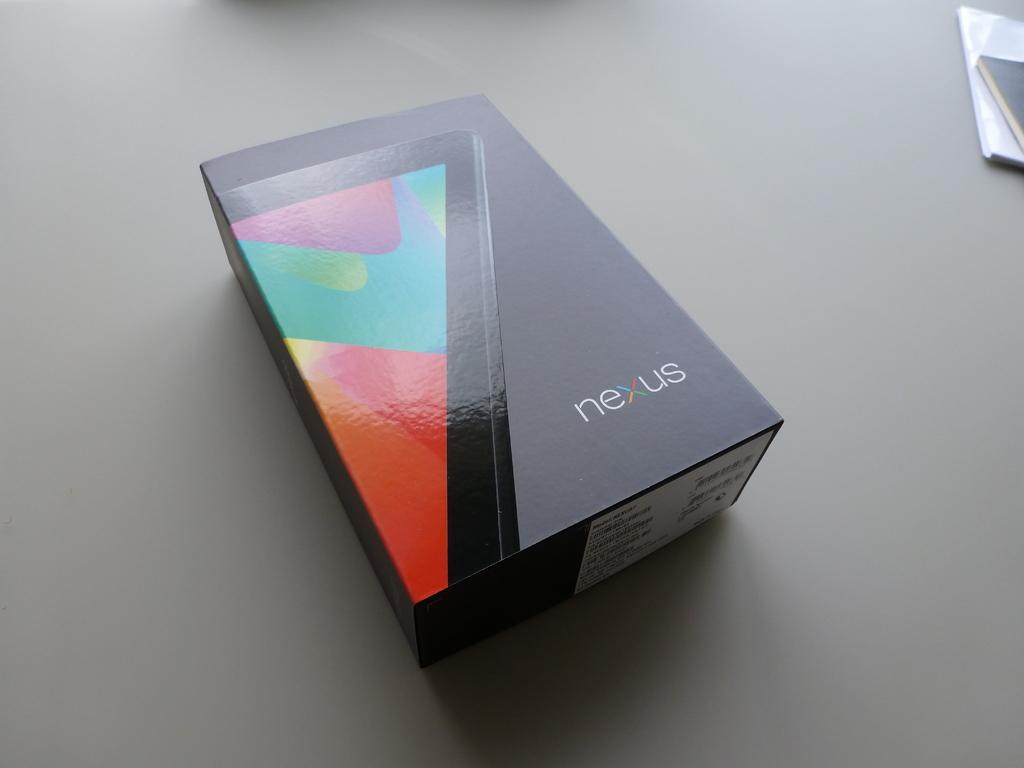What company makes this device?
Give a very brief answer. Nexus. Whats the device in the box?
Your answer should be very brief. Nexus. 